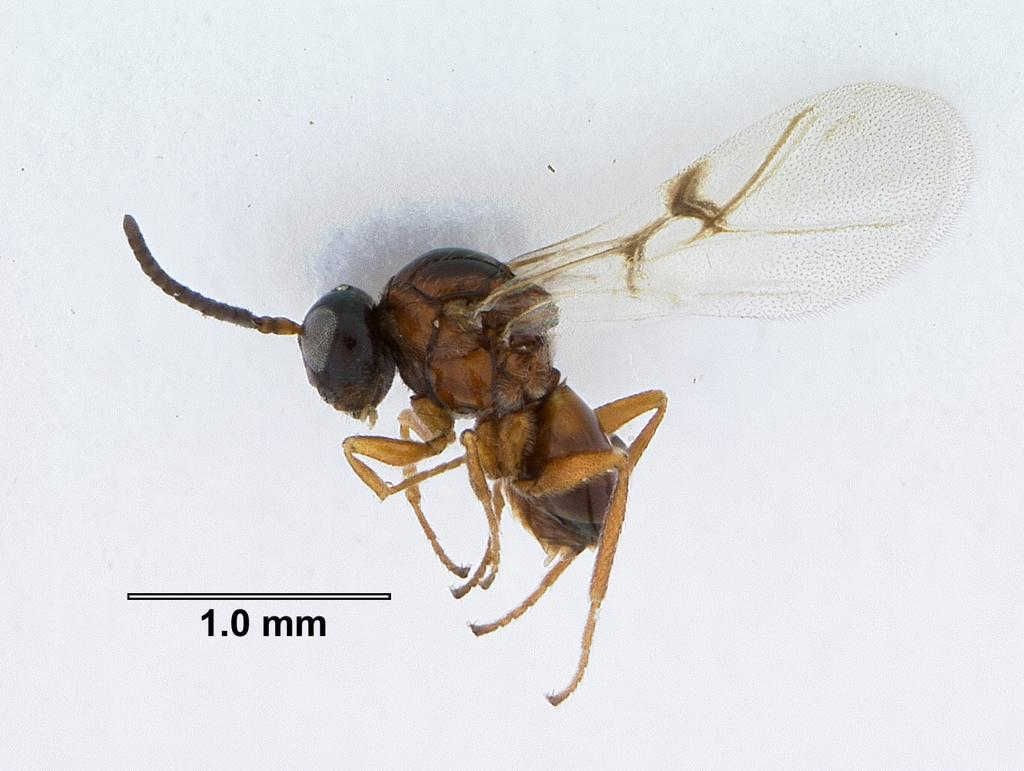What is the main subject of the image? The main subject of the image is a fly. Where is the fly located in the image? The fly is in the center of the image. What is the color of the surface the fly is on? The fly is on a white surface. Are there any words or letters visible in the image? Yes, there is some text visible in the image. Can you see any ladybugs crawling on the cave in the image? There is no cave or ladybugs present in the image; it features a fly on a white surface with some text. 